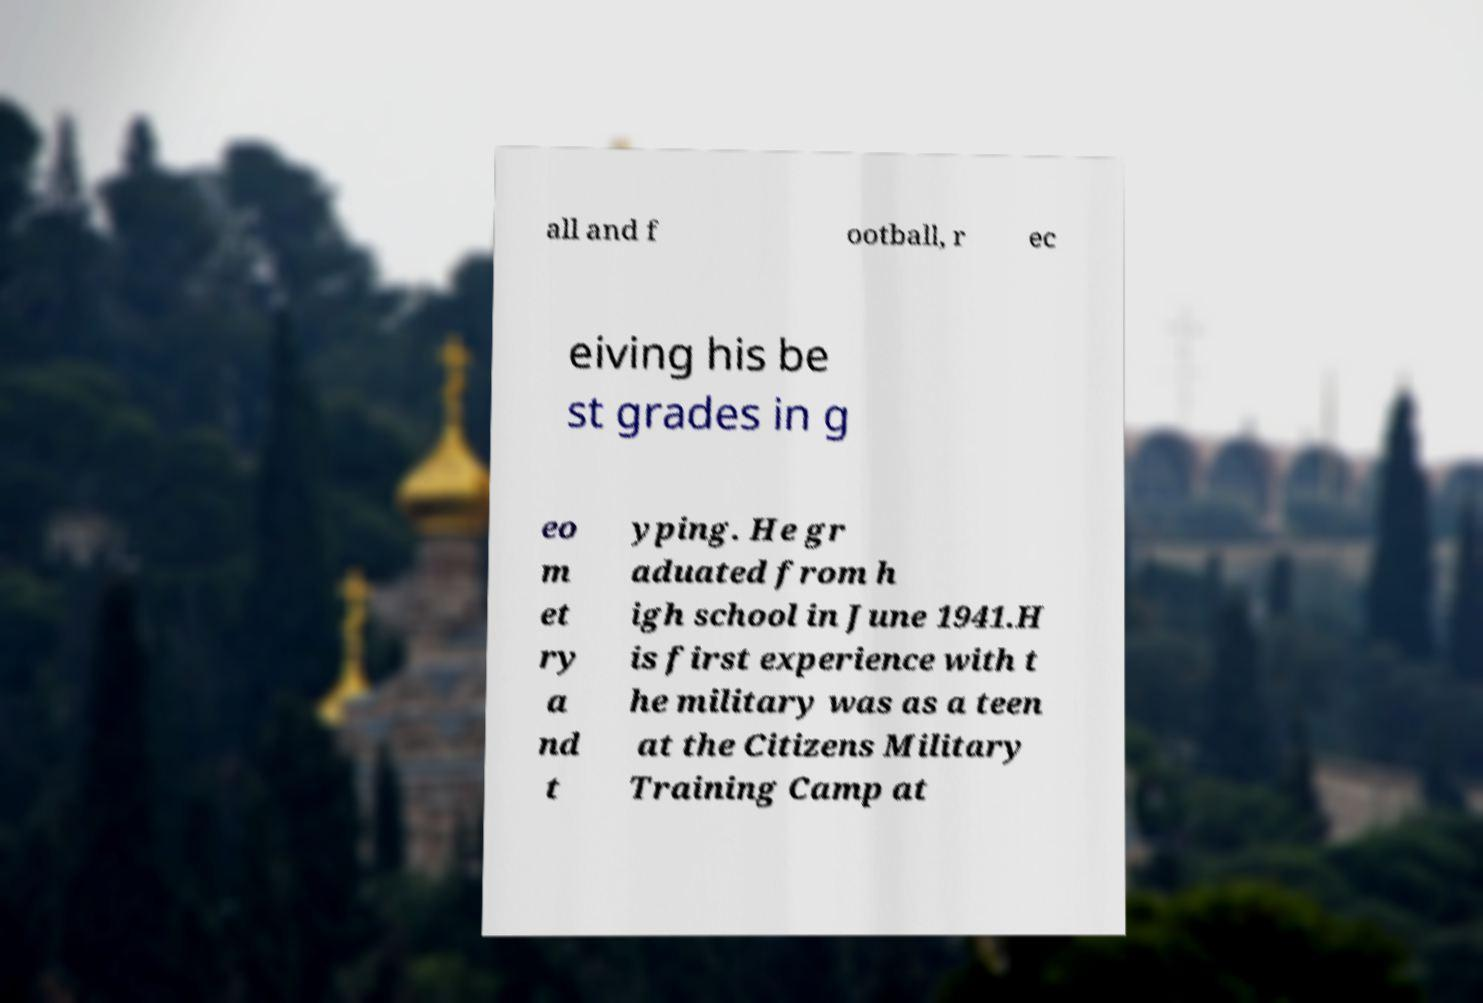What messages or text are displayed in this image? I need them in a readable, typed format. all and f ootball, r ec eiving his be st grades in g eo m et ry a nd t yping. He gr aduated from h igh school in June 1941.H is first experience with t he military was as a teen at the Citizens Military Training Camp at 